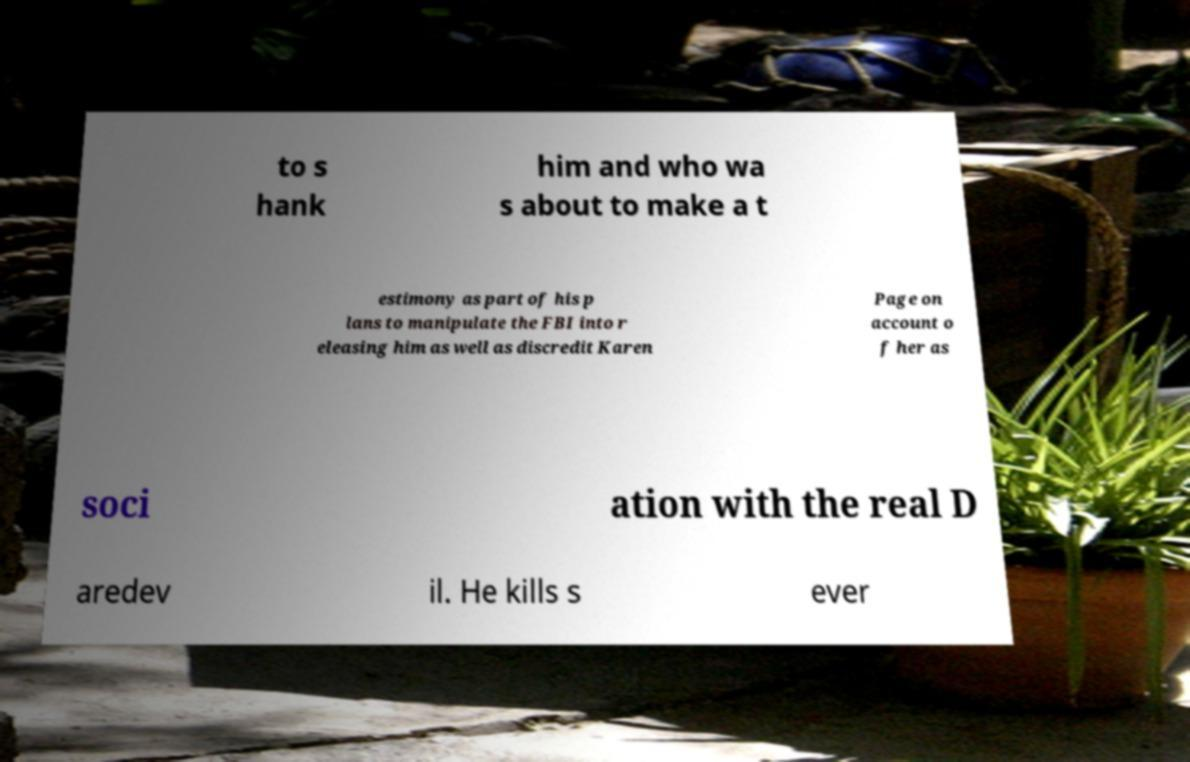Could you extract and type out the text from this image? to s hank him and who wa s about to make a t estimony as part of his p lans to manipulate the FBI into r eleasing him as well as discredit Karen Page on account o f her as soci ation with the real D aredev il. He kills s ever 